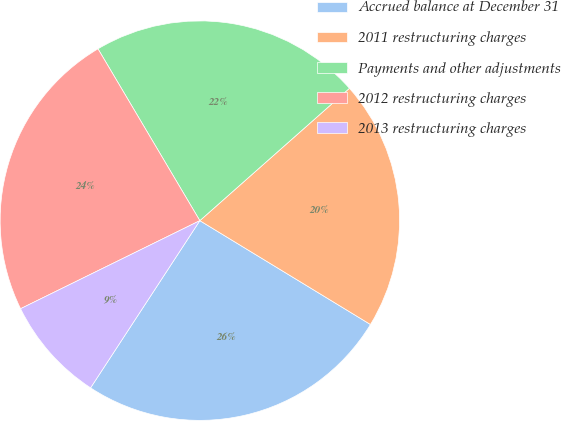Convert chart. <chart><loc_0><loc_0><loc_500><loc_500><pie_chart><fcel>Accrued balance at December 31<fcel>2011 restructuring charges<fcel>Payments and other adjustments<fcel>2012 restructuring charges<fcel>2013 restructuring charges<nl><fcel>25.51%<fcel>20.23%<fcel>21.99%<fcel>23.75%<fcel>8.52%<nl></chart> 